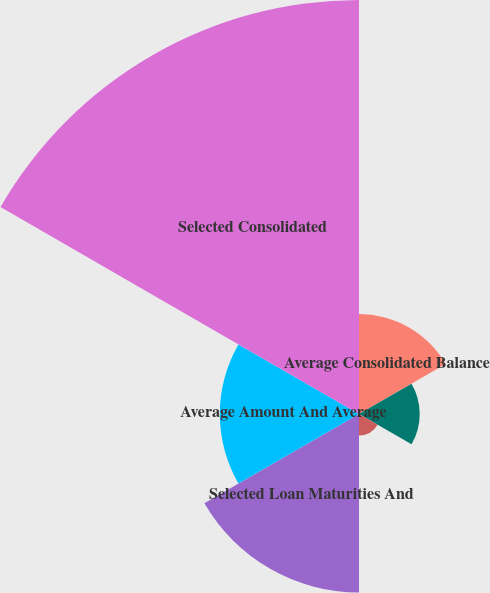Convert chart to OTSL. <chart><loc_0><loc_0><loc_500><loc_500><pie_chart><fcel>Average Consolidated Balance<fcel>Analysis Of Year-To-Year<fcel>Maturities And<fcel>Selected Loan Maturities And<fcel>Average Amount And Average<fcel>Selected Consolidated<nl><fcel>10.94%<fcel>6.64%<fcel>2.35%<fcel>19.53%<fcel>15.23%<fcel>45.3%<nl></chart> 